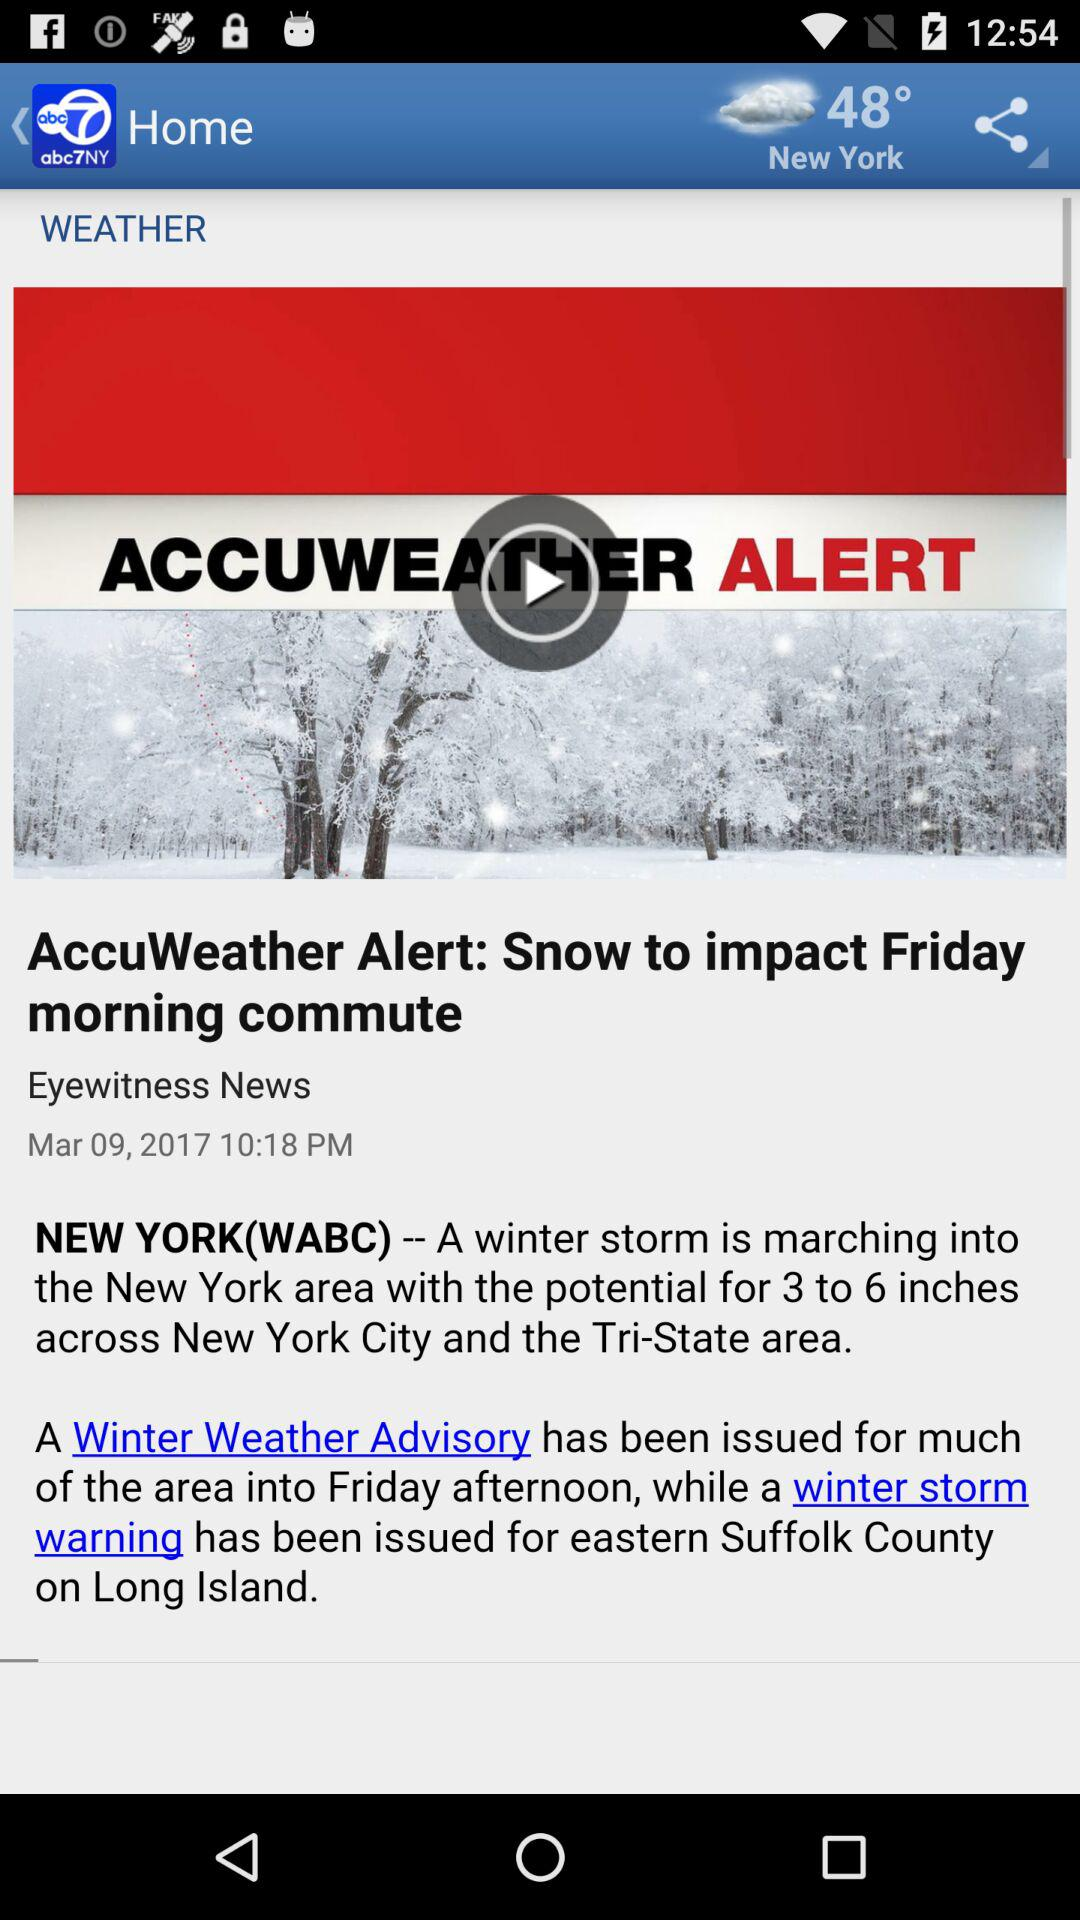What is the weather in New York? The weather is cloudy. 